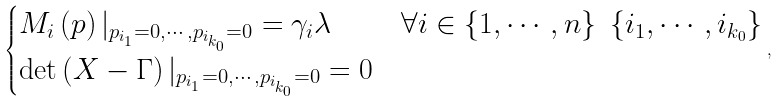Convert formula to latex. <formula><loc_0><loc_0><loc_500><loc_500>\begin{cases} M _ { i } \left ( p \right ) | _ { p _ { i _ { 1 } } = 0 , \cdots , p _ { i _ { k _ { 0 } } } = 0 } = \gamma _ { i } \lambda & \forall i \in \left \{ 1 , \cdots , n \right \} \ \left \{ i _ { 1 } , \cdots , i _ { k _ { 0 } } \right \} \\ \det \left ( X - \Gamma \right ) | _ { p _ { i _ { 1 } } = 0 , \cdots , p _ { i _ { k _ { 0 } } } = 0 } = 0 \end{cases} ,</formula> 